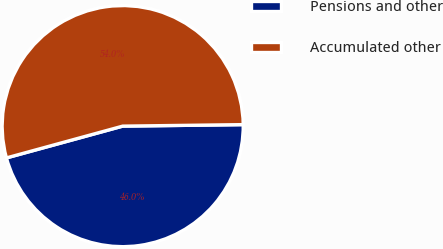Convert chart to OTSL. <chart><loc_0><loc_0><loc_500><loc_500><pie_chart><fcel>Pensions and other<fcel>Accumulated other<nl><fcel>45.95%<fcel>54.05%<nl></chart> 